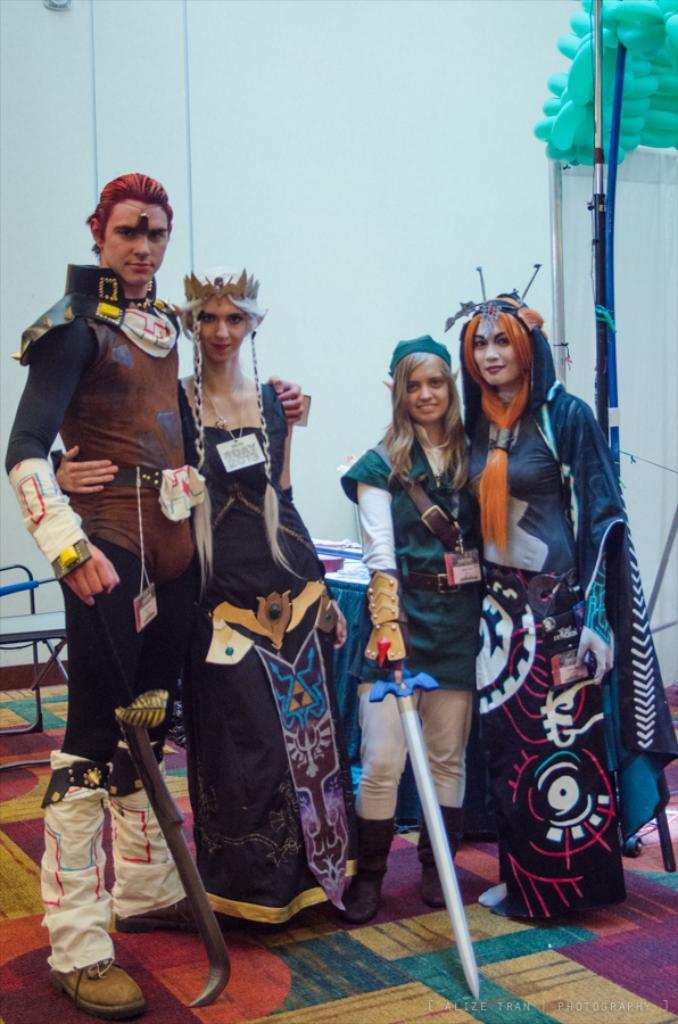What are the people in the image wearing? The people in the image are wearing costumes. What are the people holding in their hands? The people are holding weapons. What can be seen in the background of the image? There is a wall, a table, and a chair in the background of the image, along with other things. What is the floor covering in the image? The floor has a carpet. How does the writer distribute the books in the image? There is no writer or books present in the image; it features people wearing costumes and holding weapons. 